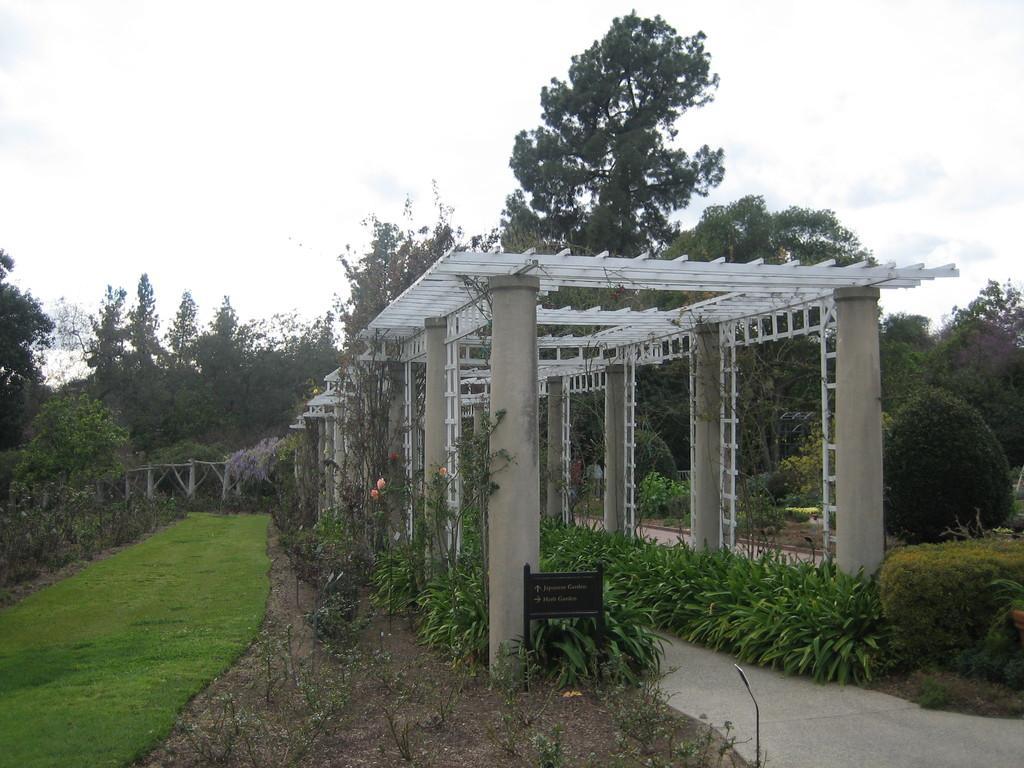Please provide a concise description of this image. We can see pillars,plants and grass. In the background we can see trees and sky. 